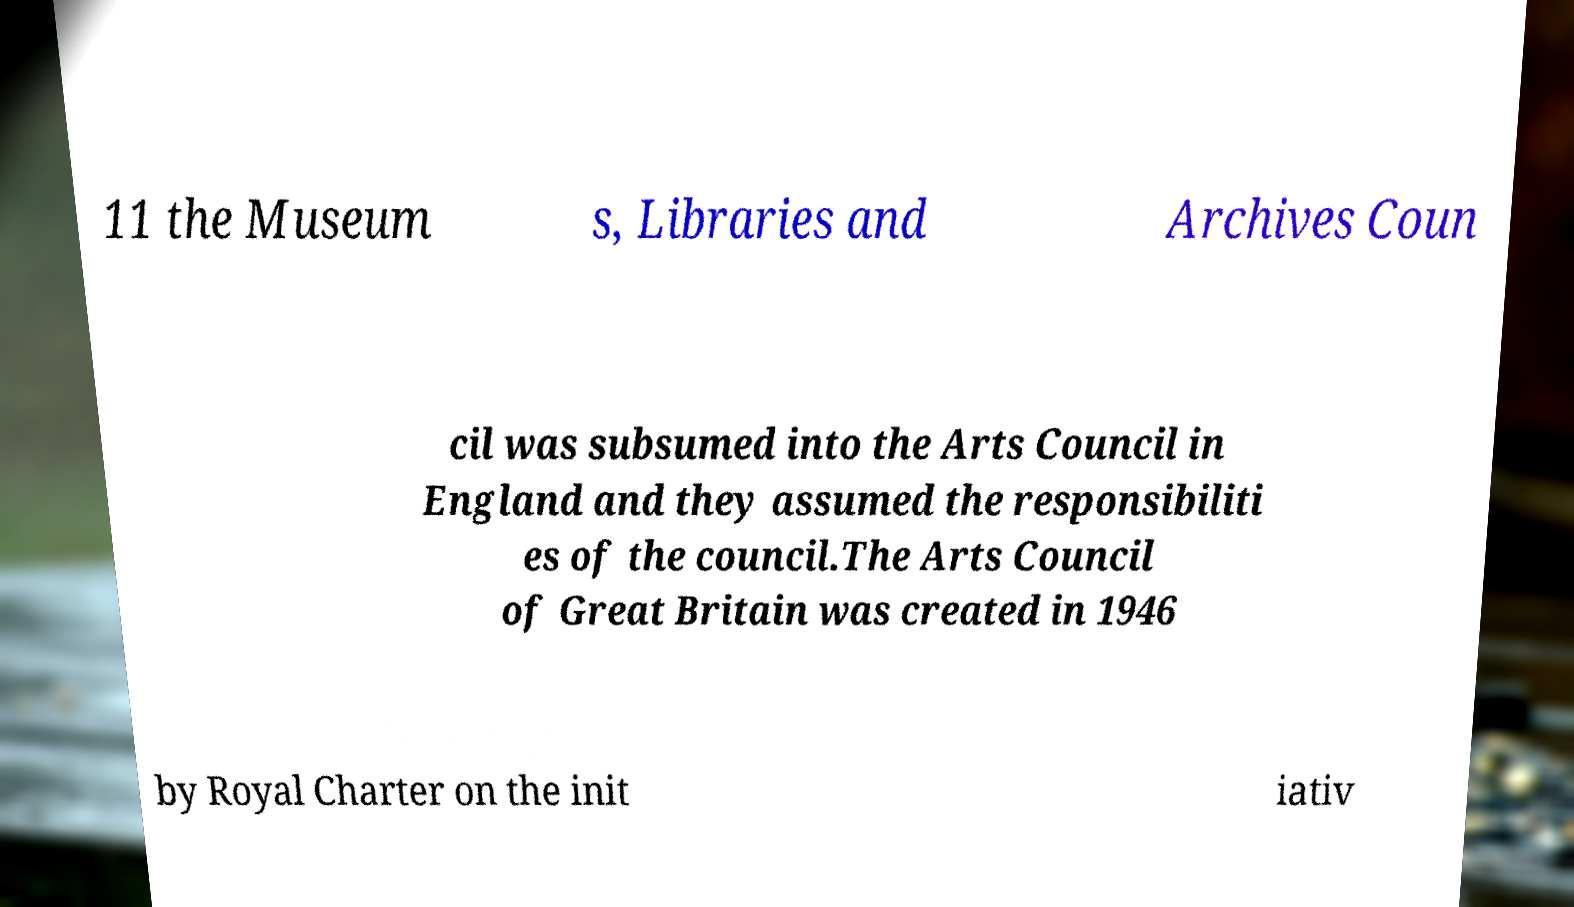Can you read and provide the text displayed in the image?This photo seems to have some interesting text. Can you extract and type it out for me? 11 the Museum s, Libraries and Archives Coun cil was subsumed into the Arts Council in England and they assumed the responsibiliti es of the council.The Arts Council of Great Britain was created in 1946 by Royal Charter on the init iativ 